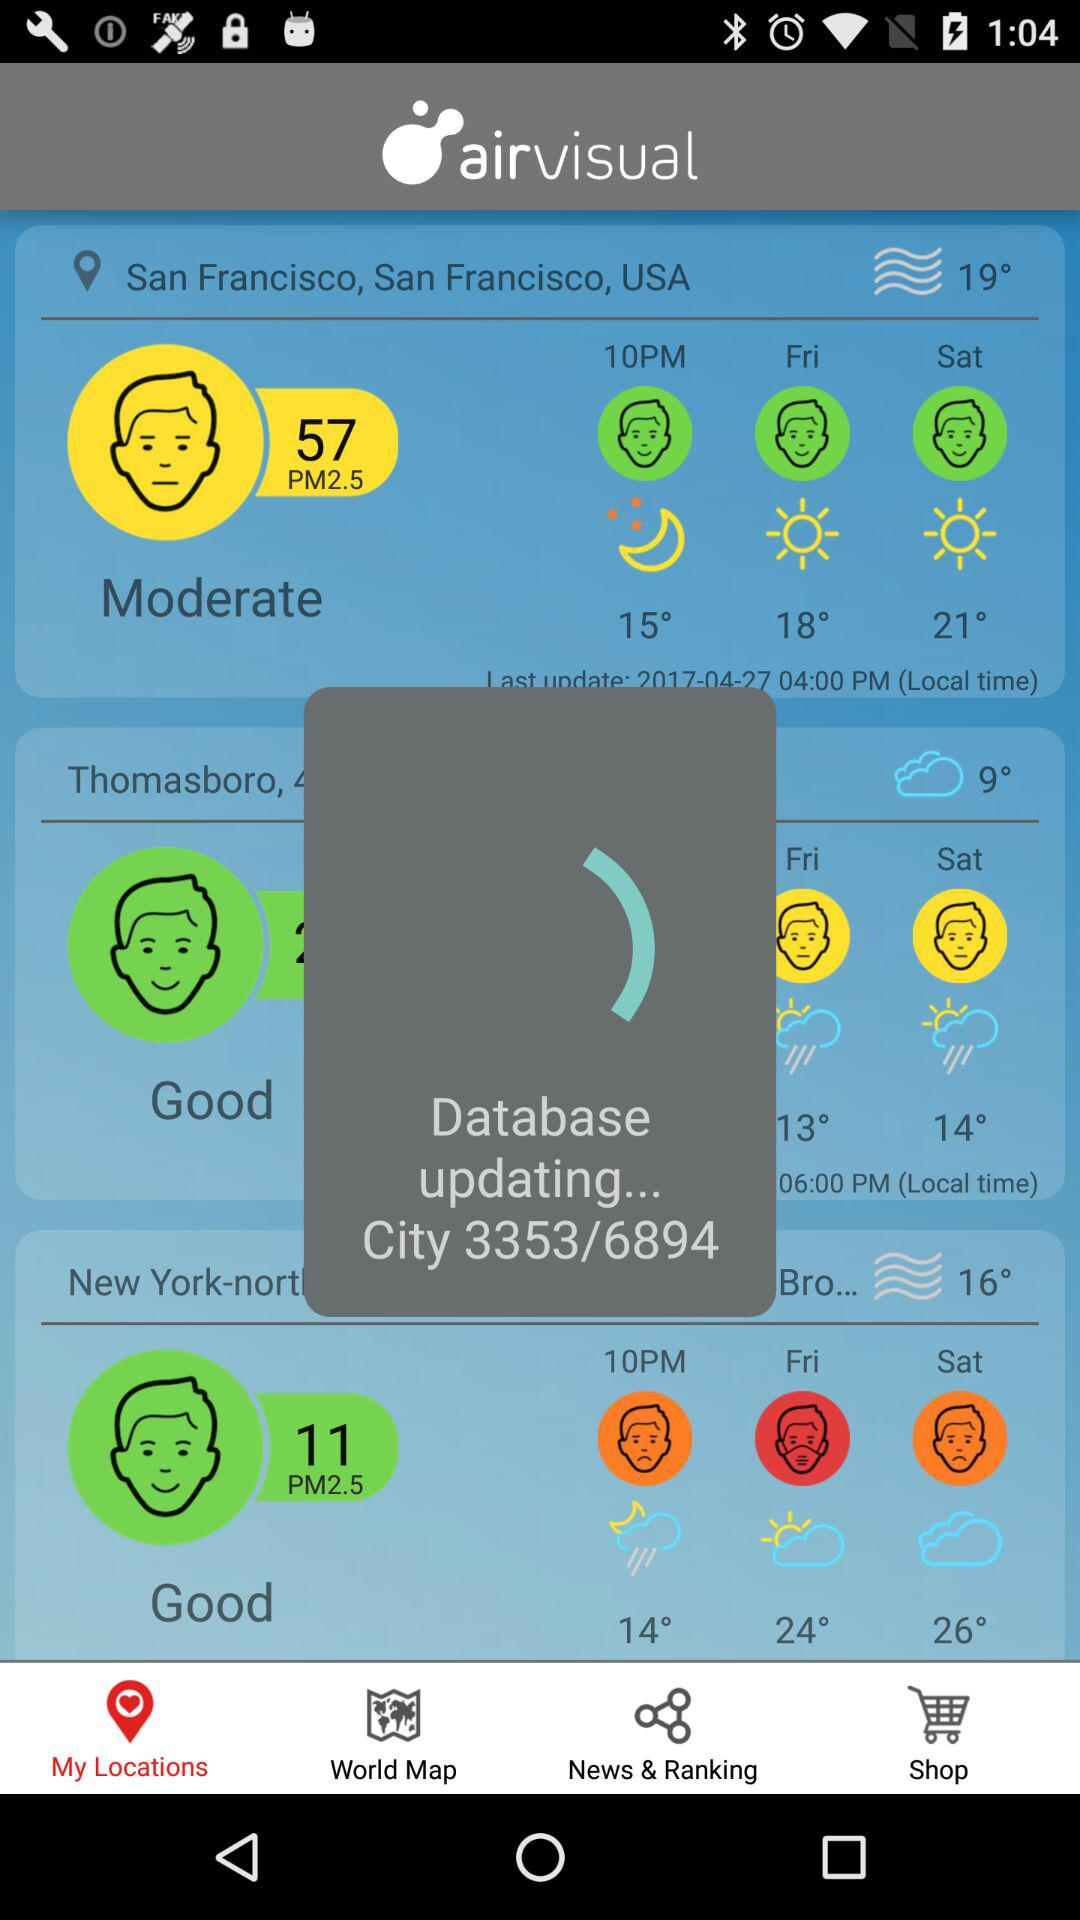What is the temperature in the USA? The temperature is 19 degrees. 